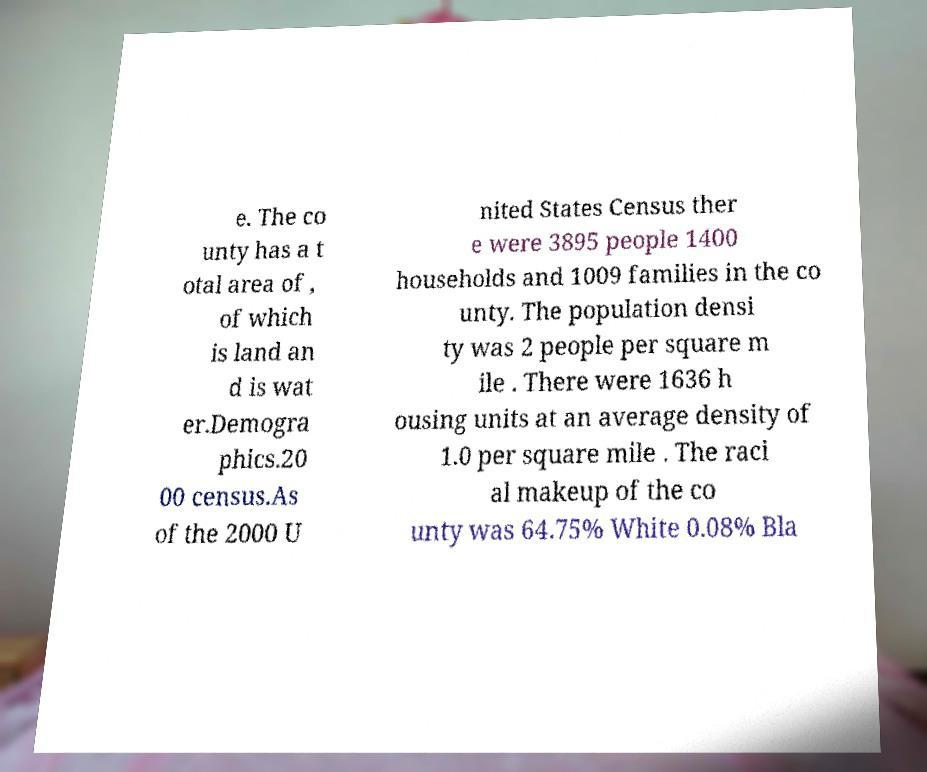Please read and relay the text visible in this image. What does it say? e. The co unty has a t otal area of , of which is land an d is wat er.Demogra phics.20 00 census.As of the 2000 U nited States Census ther e were 3895 people 1400 households and 1009 families in the co unty. The population densi ty was 2 people per square m ile . There were 1636 h ousing units at an average density of 1.0 per square mile . The raci al makeup of the co unty was 64.75% White 0.08% Bla 